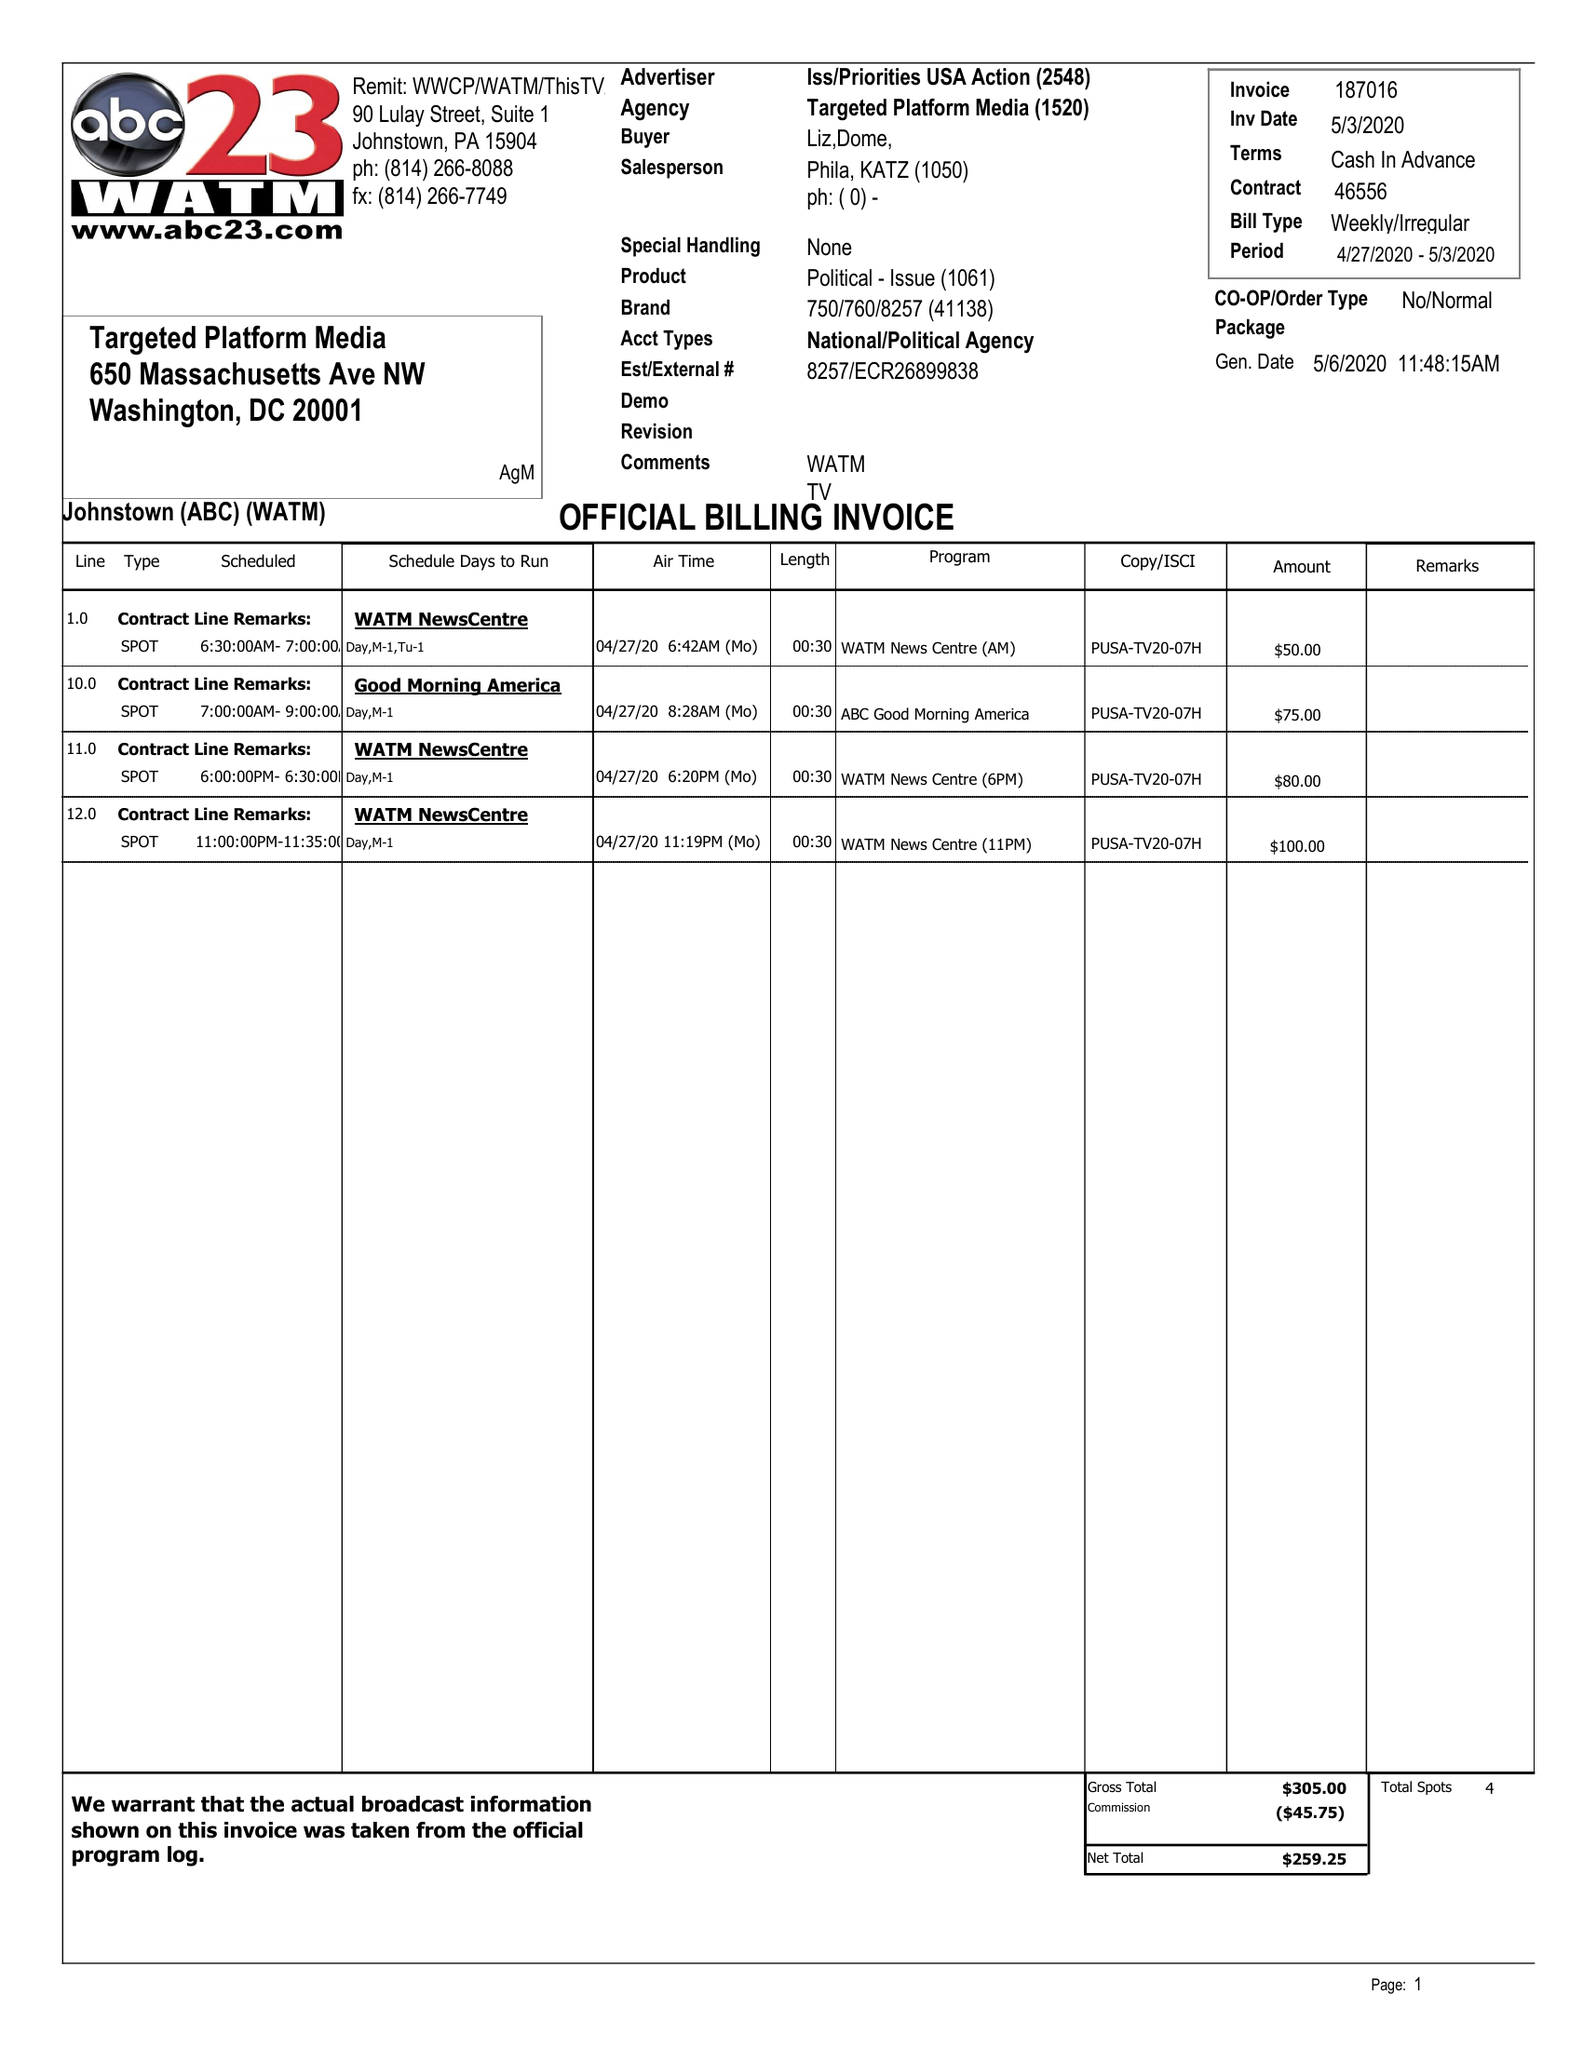What is the value for the flight_to?
Answer the question using a single word or phrase. 05/03/20 